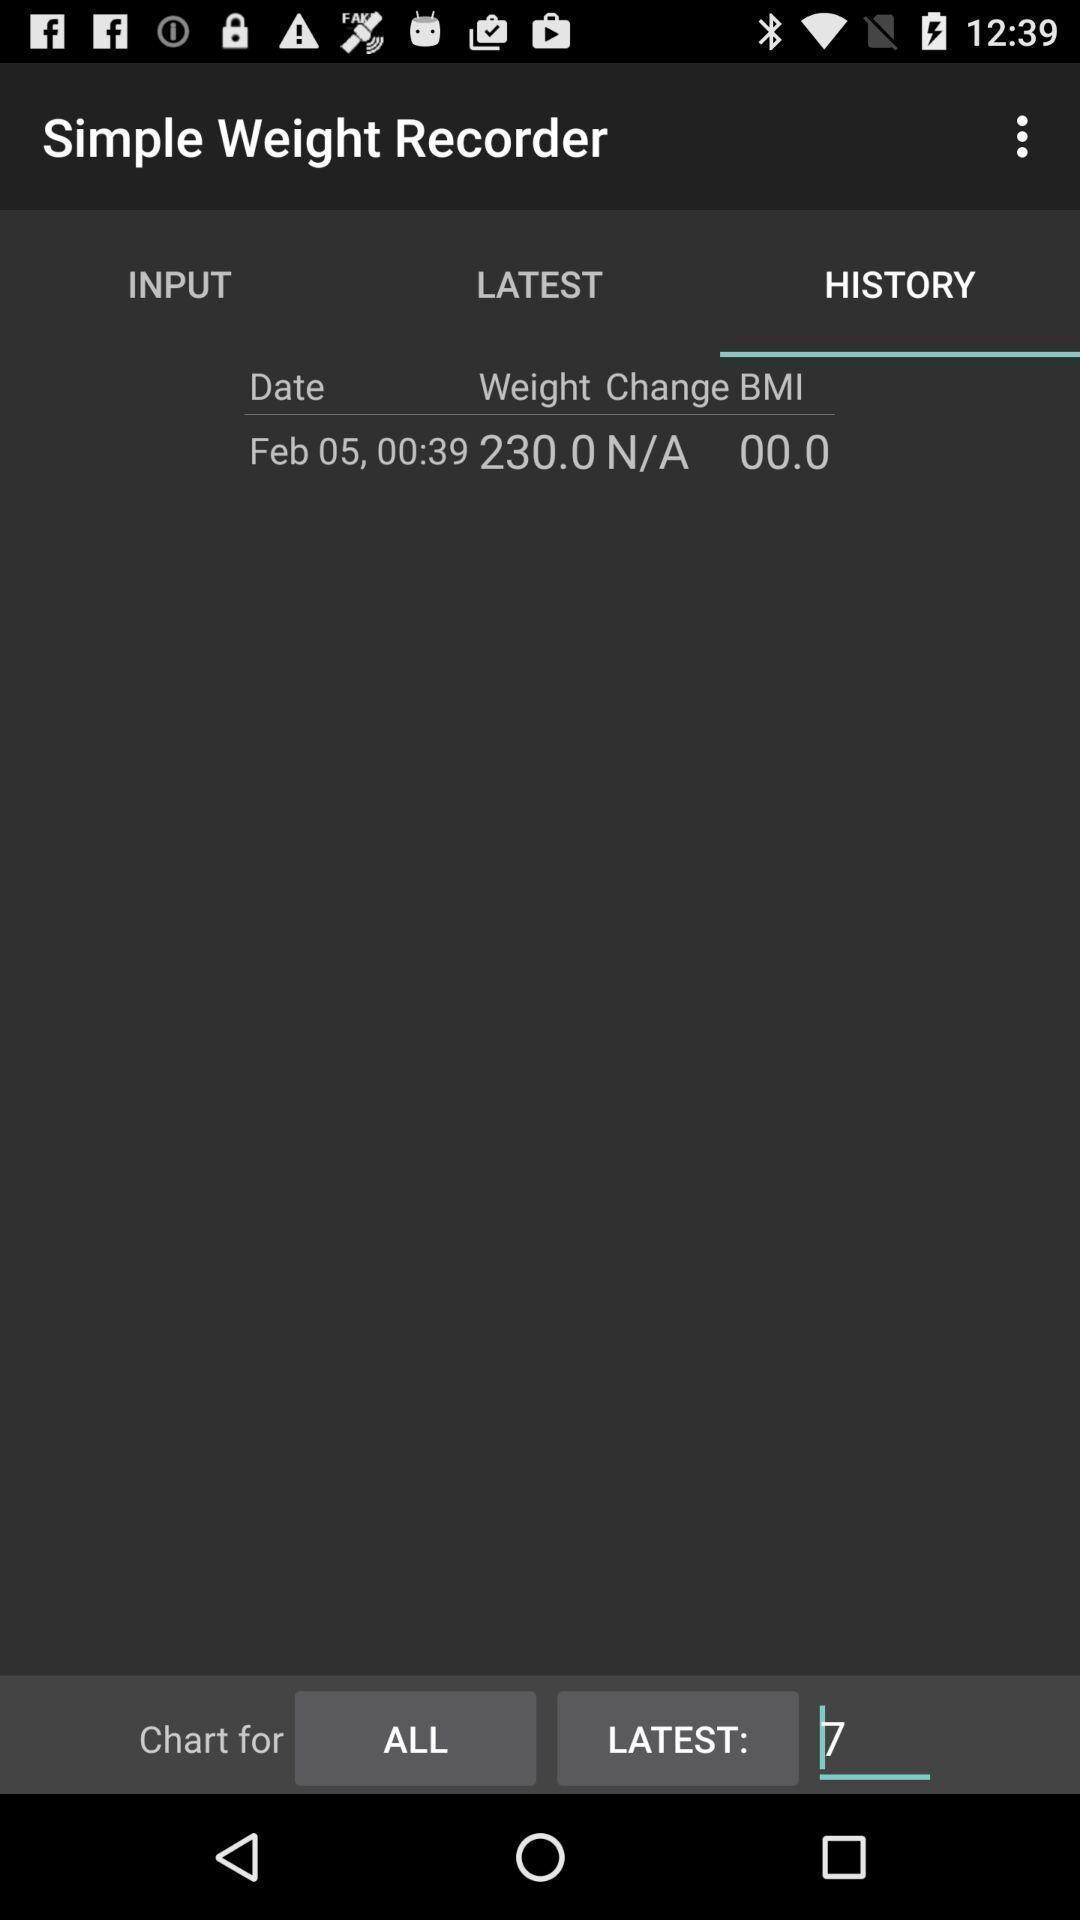Provide a description of this screenshot. Page asking input to record details. 